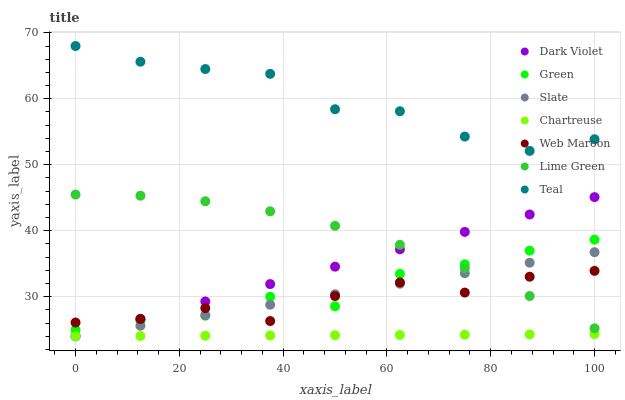Does Chartreuse have the minimum area under the curve?
Answer yes or no. Yes. Does Teal have the maximum area under the curve?
Answer yes or no. Yes. Does Web Maroon have the minimum area under the curve?
Answer yes or no. No. Does Web Maroon have the maximum area under the curve?
Answer yes or no. No. Is Slate the smoothest?
Answer yes or no. Yes. Is Web Maroon the roughest?
Answer yes or no. Yes. Is Dark Violet the smoothest?
Answer yes or no. No. Is Dark Violet the roughest?
Answer yes or no. No. Does Slate have the lowest value?
Answer yes or no. Yes. Does Web Maroon have the lowest value?
Answer yes or no. No. Does Teal have the highest value?
Answer yes or no. Yes. Does Web Maroon have the highest value?
Answer yes or no. No. Is Web Maroon less than Teal?
Answer yes or no. Yes. Is Web Maroon greater than Chartreuse?
Answer yes or no. Yes. Does Lime Green intersect Web Maroon?
Answer yes or no. Yes. Is Lime Green less than Web Maroon?
Answer yes or no. No. Is Lime Green greater than Web Maroon?
Answer yes or no. No. Does Web Maroon intersect Teal?
Answer yes or no. No. 